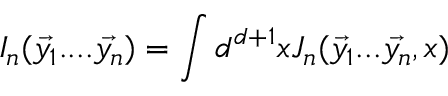Convert formula to latex. <formula><loc_0><loc_0><loc_500><loc_500>I _ { n } ( \vec { y _ { 1 } } \cdots \vec { y _ { n } } ) = \int d ^ { d + 1 } x J _ { n } ( \vec { y _ { 1 } } \dots \vec { y _ { n } } , x )</formula> 